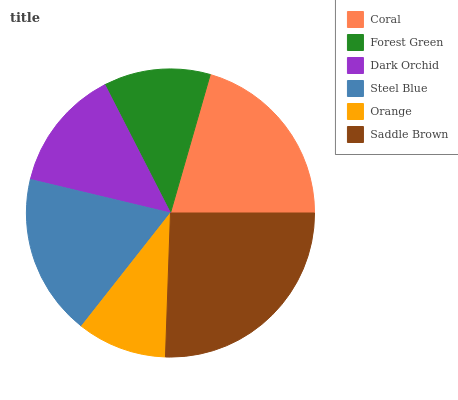Is Orange the minimum?
Answer yes or no. Yes. Is Saddle Brown the maximum?
Answer yes or no. Yes. Is Forest Green the minimum?
Answer yes or no. No. Is Forest Green the maximum?
Answer yes or no. No. Is Coral greater than Forest Green?
Answer yes or no. Yes. Is Forest Green less than Coral?
Answer yes or no. Yes. Is Forest Green greater than Coral?
Answer yes or no. No. Is Coral less than Forest Green?
Answer yes or no. No. Is Steel Blue the high median?
Answer yes or no. Yes. Is Dark Orchid the low median?
Answer yes or no. Yes. Is Saddle Brown the high median?
Answer yes or no. No. Is Forest Green the low median?
Answer yes or no. No. 